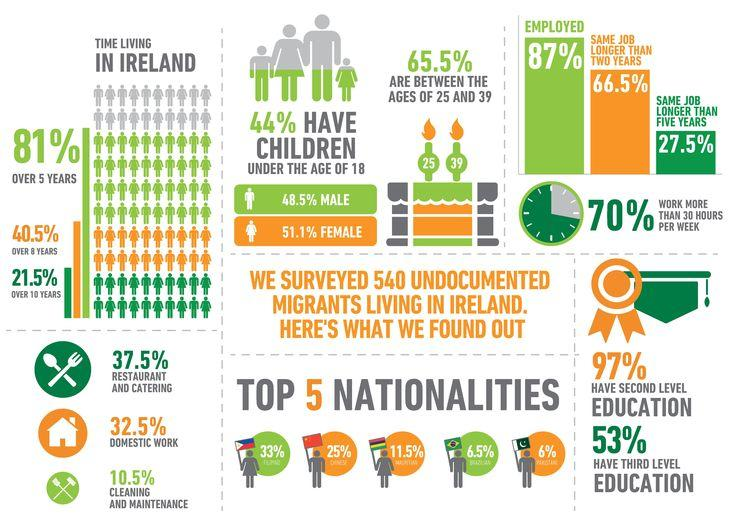Outline some significant characteristics in this image. According to a study, 66.5% of people in Ireland have the same job for more than two years. According to recent statistics, 37.5% of the Irish population is involved in the restaurant and catering industry. According to a recent survey, 32.5% of the Irish population are involved in domestic works. In Ireland, approximately 87% of the people are employed. According to recent data, approximately 27.5% of people in Ireland have the same job for more than 5 years. 